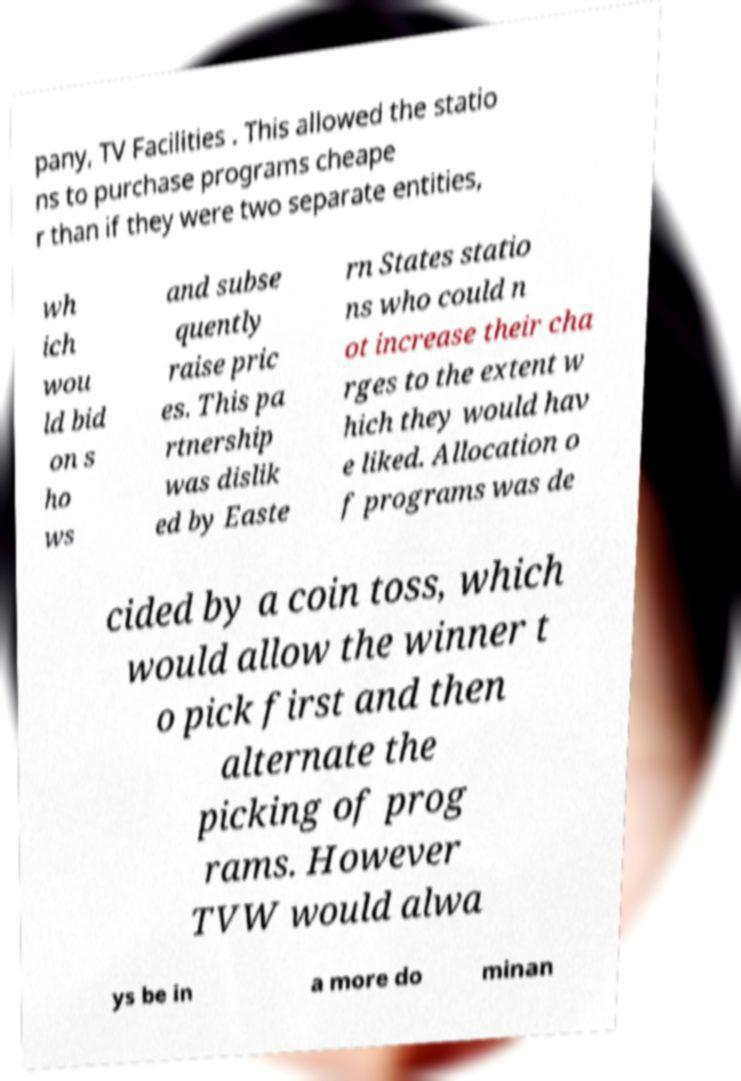Can you read and provide the text displayed in the image?This photo seems to have some interesting text. Can you extract and type it out for me? pany, TV Facilities . This allowed the statio ns to purchase programs cheape r than if they were two separate entities, wh ich wou ld bid on s ho ws and subse quently raise pric es. This pa rtnership was dislik ed by Easte rn States statio ns who could n ot increase their cha rges to the extent w hich they would hav e liked. Allocation o f programs was de cided by a coin toss, which would allow the winner t o pick first and then alternate the picking of prog rams. However TVW would alwa ys be in a more do minan 